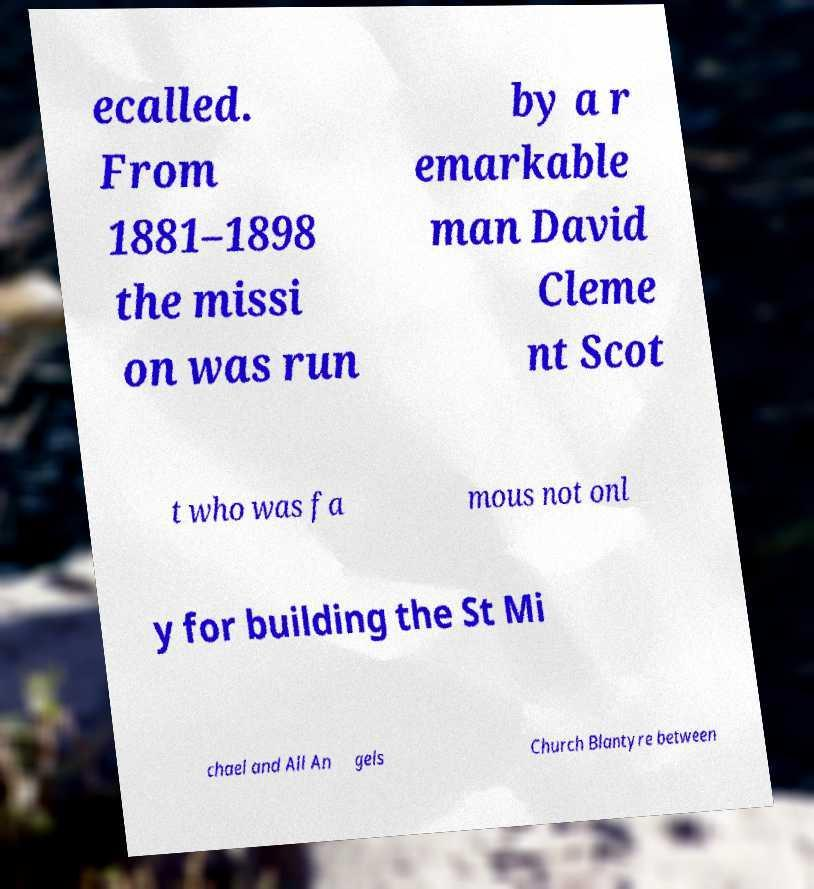Can you accurately transcribe the text from the provided image for me? ecalled. From 1881–1898 the missi on was run by a r emarkable man David Cleme nt Scot t who was fa mous not onl y for building the St Mi chael and All An gels Church Blantyre between 